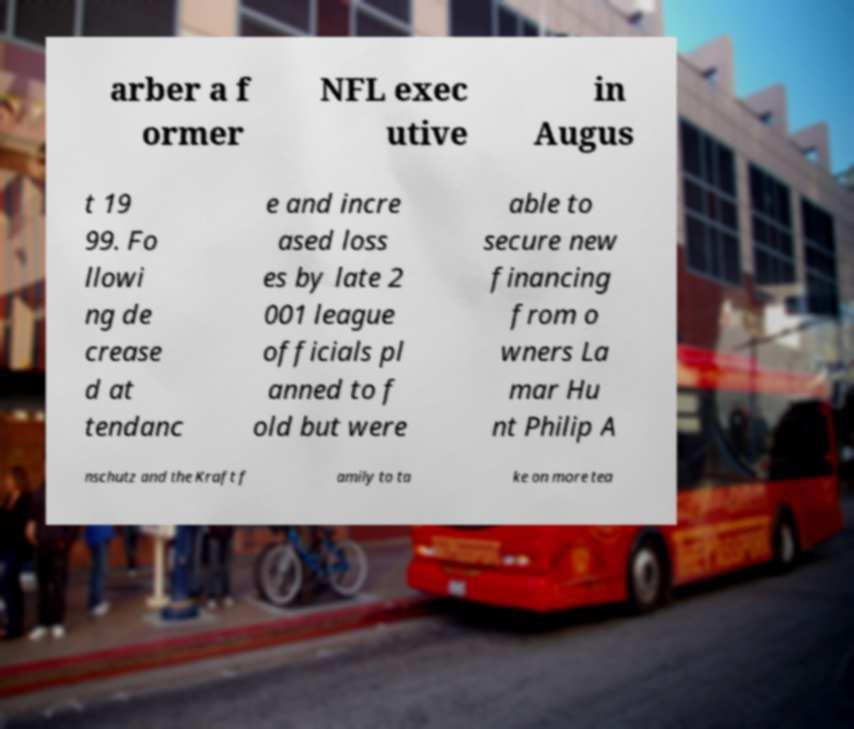For documentation purposes, I need the text within this image transcribed. Could you provide that? arber a f ormer NFL exec utive in Augus t 19 99. Fo llowi ng de crease d at tendanc e and incre ased loss es by late 2 001 league officials pl anned to f old but were able to secure new financing from o wners La mar Hu nt Philip A nschutz and the Kraft f amily to ta ke on more tea 